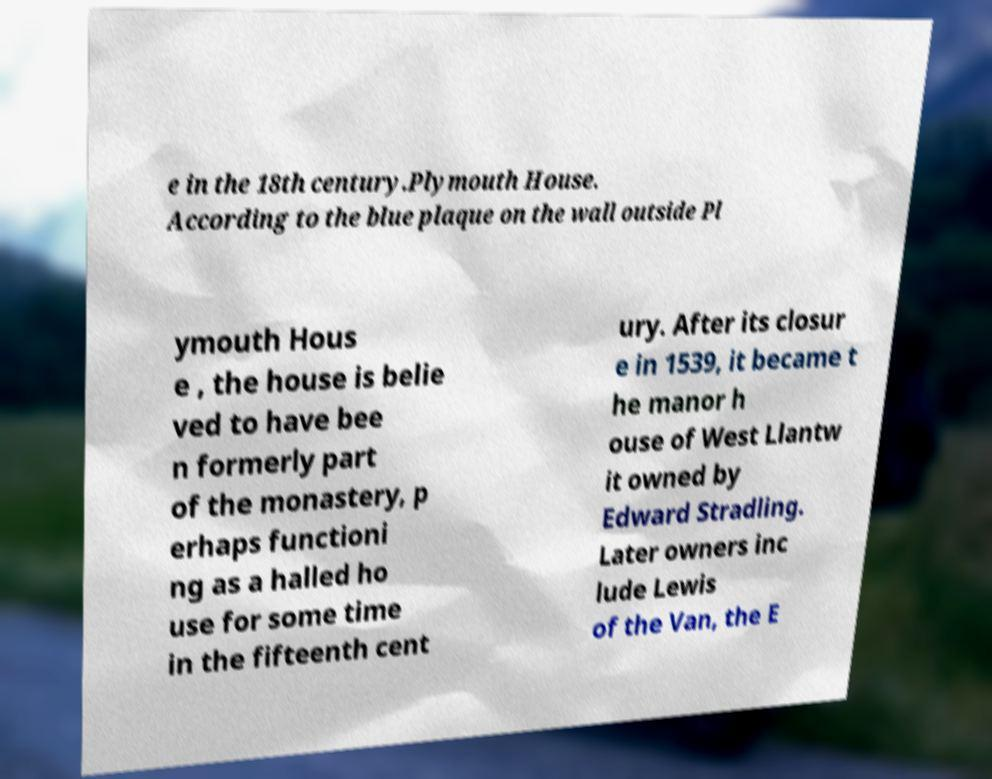Can you read and provide the text displayed in the image?This photo seems to have some interesting text. Can you extract and type it out for me? e in the 18th century.Plymouth House. According to the blue plaque on the wall outside Pl ymouth Hous e , the house is belie ved to have bee n formerly part of the monastery, p erhaps functioni ng as a halled ho use for some time in the fifteenth cent ury. After its closur e in 1539, it became t he manor h ouse of West Llantw it owned by Edward Stradling. Later owners inc lude Lewis of the Van, the E 